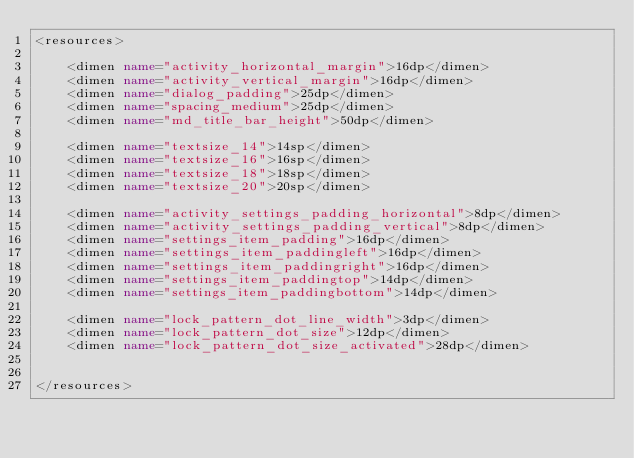Convert code to text. <code><loc_0><loc_0><loc_500><loc_500><_XML_><resources>

    <dimen name="activity_horizontal_margin">16dp</dimen>
    <dimen name="activity_vertical_margin">16dp</dimen>
    <dimen name="dialog_padding">25dp</dimen>
    <dimen name="spacing_medium">25dp</dimen>
    <dimen name="md_title_bar_height">50dp</dimen>

    <dimen name="textsize_14">14sp</dimen>
    <dimen name="textsize_16">16sp</dimen>
    <dimen name="textsize_18">18sp</dimen>
    <dimen name="textsize_20">20sp</dimen>

    <dimen name="activity_settings_padding_horizontal">8dp</dimen>
    <dimen name="activity_settings_padding_vertical">8dp</dimen>
    <dimen name="settings_item_padding">16dp</dimen>
    <dimen name="settings_item_paddingleft">16dp</dimen>
    <dimen name="settings_item_paddingright">16dp</dimen>
    <dimen name="settings_item_paddingtop">14dp</dimen>
    <dimen name="settings_item_paddingbottom">14dp</dimen>

    <dimen name="lock_pattern_dot_line_width">3dp</dimen>
    <dimen name="lock_pattern_dot_size">12dp</dimen>
    <dimen name="lock_pattern_dot_size_activated">28dp</dimen>


</resources></code> 